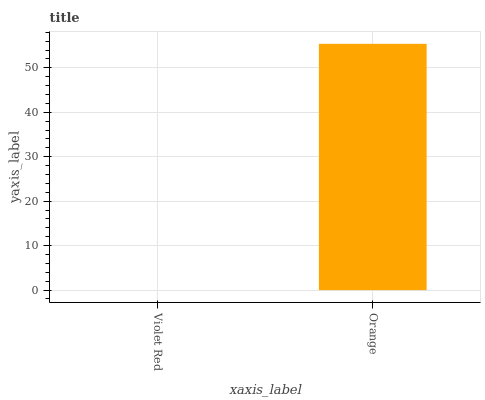Is Orange the minimum?
Answer yes or no. No. Is Orange greater than Violet Red?
Answer yes or no. Yes. Is Violet Red less than Orange?
Answer yes or no. Yes. Is Violet Red greater than Orange?
Answer yes or no. No. Is Orange less than Violet Red?
Answer yes or no. No. Is Orange the high median?
Answer yes or no. Yes. Is Violet Red the low median?
Answer yes or no. Yes. Is Violet Red the high median?
Answer yes or no. No. Is Orange the low median?
Answer yes or no. No. 